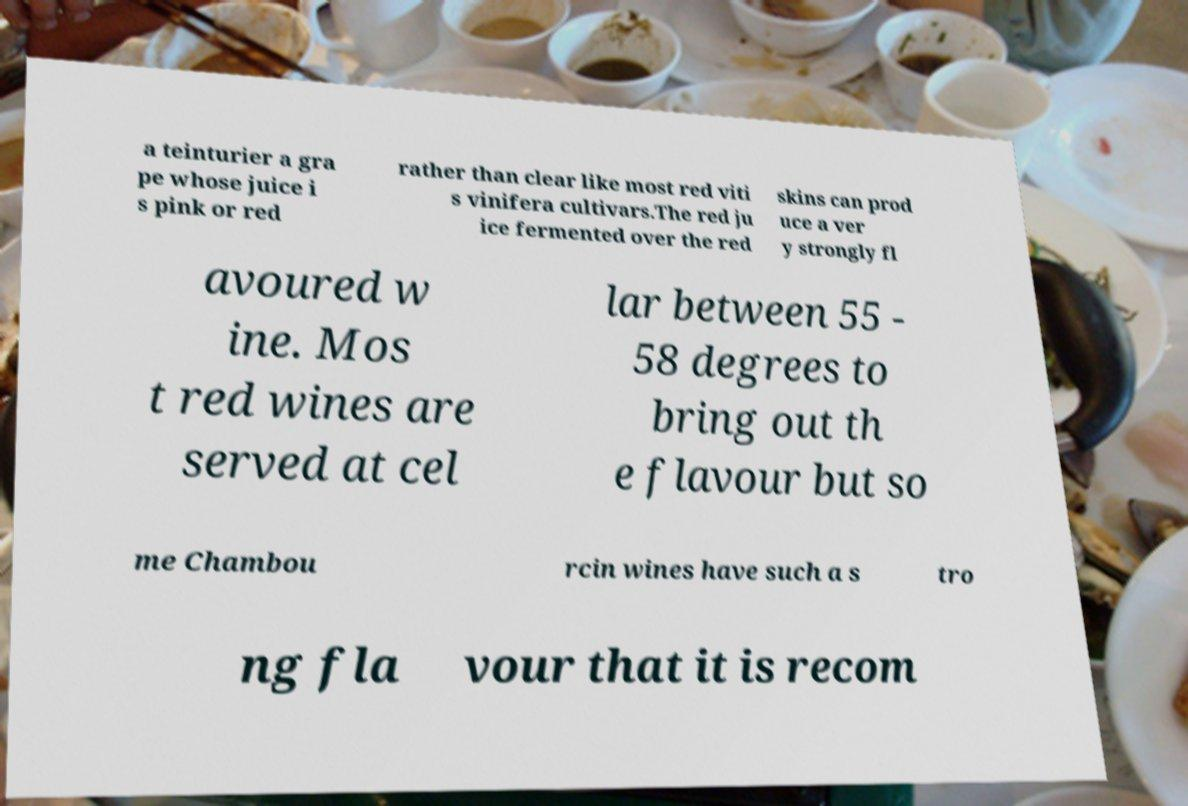Please read and relay the text visible in this image. What does it say? a teinturier a gra pe whose juice i s pink or red rather than clear like most red viti s vinifera cultivars.The red ju ice fermented over the red skins can prod uce a ver y strongly fl avoured w ine. Mos t red wines are served at cel lar between 55 - 58 degrees to bring out th e flavour but so me Chambou rcin wines have such a s tro ng fla vour that it is recom 